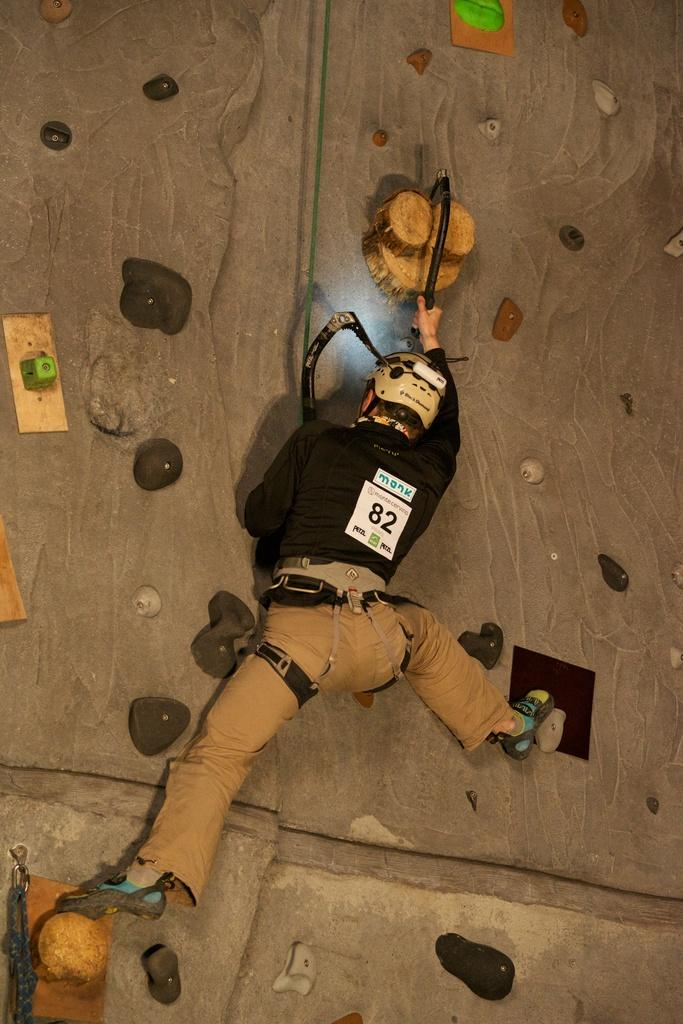What is the person in the image doing? The person is performing indoor climbing. What safety equipment is the person wearing? The person is wearing a helmet. What is the person holding to assist with the climbing? The person is holding a tool for climbing. What type of building is being attacked by the person in the image? There is no building or attack present in the image; it features a person performing indoor climbing. How old is the boy in the image? There is no boy present in the image; it features a person performing indoor climbing. 